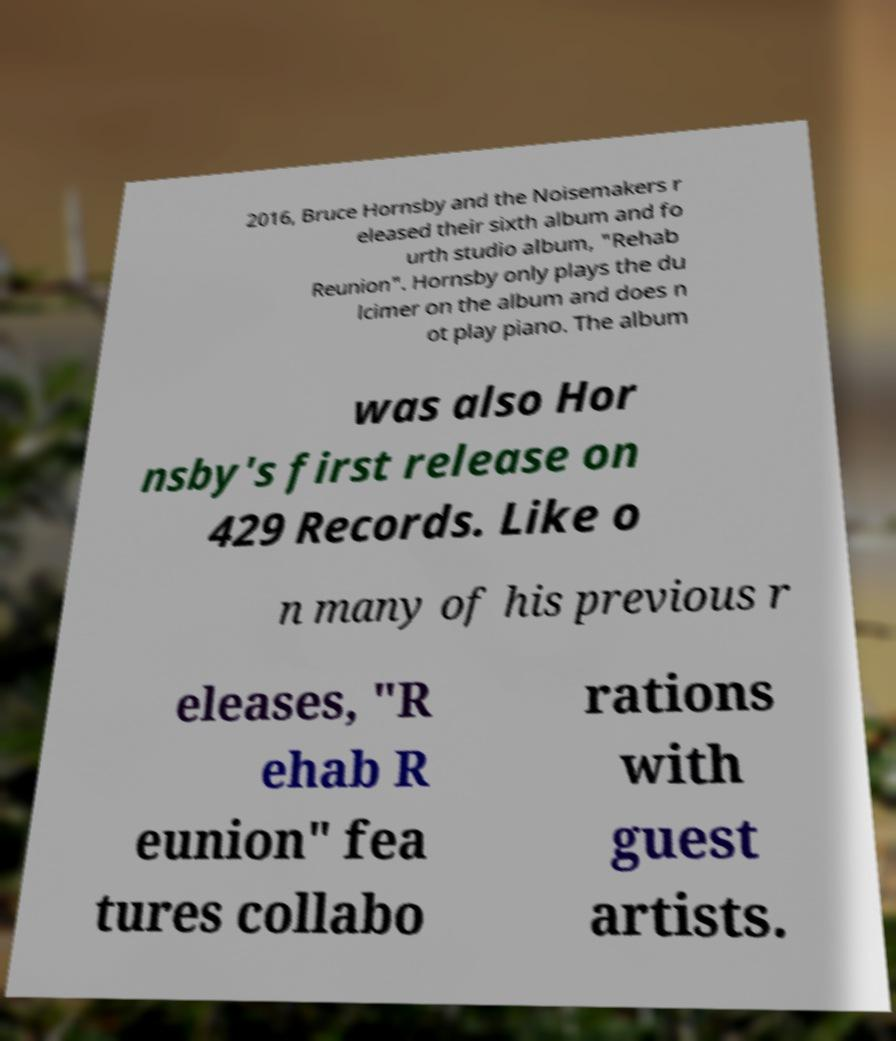Could you extract and type out the text from this image? 2016, Bruce Hornsby and the Noisemakers r eleased their sixth album and fo urth studio album, "Rehab Reunion". Hornsby only plays the du lcimer on the album and does n ot play piano. The album was also Hor nsby's first release on 429 Records. Like o n many of his previous r eleases, "R ehab R eunion" fea tures collabo rations with guest artists. 